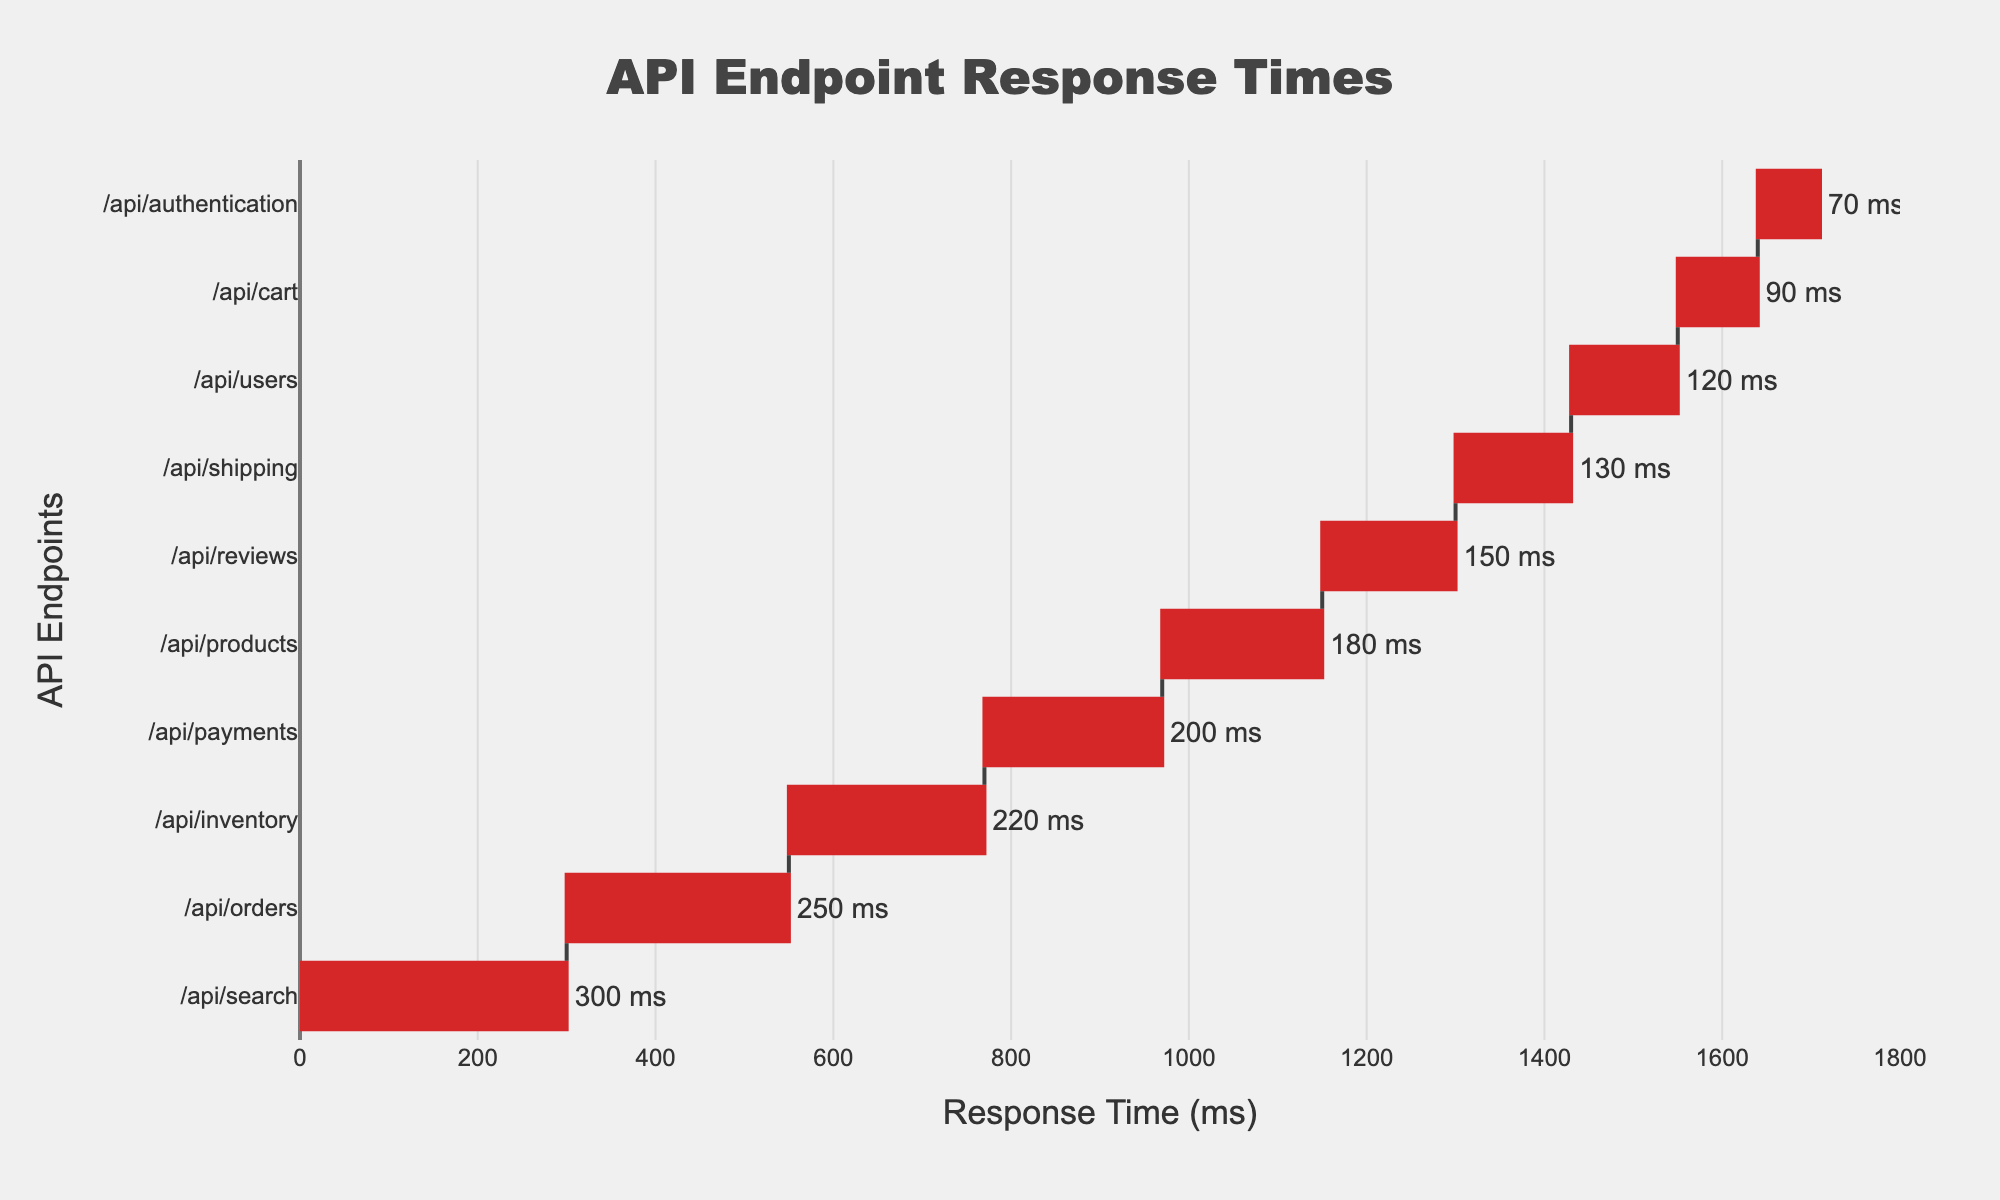What's the title of the chart? The title of the chart is prominently displayed at the top. It reads "API Endpoint Response Times."
Answer: API Endpoint Response Times How many API endpoints are displayed in the chart? To determine the number of API endpoints, count the total number of bars in the waterfall chart or refer to the number of y-axis labels.
Answer: 10 Which API endpoint has the highest response time? To find the API endpoint with the highest response time, look for the topmost bar since the data is sorted by response time in descending order.
Answer: /api/search What is the response time of the "/api/products" endpoint? Check the exact numeric value displayed at the end of the horizontal bar corresponding to the "/api/products" label. It shows "180 ms."
Answer: 180 ms Which endpoints have response times greater than 200 ms? Identify the endpoints with bars extending beyond the 200 ms mark on the x-axis or read the numeric values for each endpoint to see if they exceed 200 ms. These are "/api/search", "/api/orders", "/api/inventory", and "/api/payments."
Answer: /api/search, /api/orders, /api/inventory, /api/payments What is the difference in response time between "/api/cart" and "/api/shipping"? Find the response times for "/api/cart" and "/api/shipping" (90 ms and 130 ms, respectively). Subtract the smaller value (90 ms) from the larger value (130 ms).
Answer: 40 ms What's the average response time of the listed API endpoints? Sum all response times and divide by the number of endpoints. Total response time = 120 + 180 + 250 + 90 + 70 + 300 + 150 + 200 + 220 + 130 = 1710 ms. Number of endpoints = 10. Average response time = 1710 / 10 ms.
Answer: 171 ms How does the response time of "/api/users" compare to "/api/authentication"? Compare the numeric values of the response times for these endpoints. "/api/users" has 120 ms, and "/api/authentication" has 70 ms. "/api/users" has a higher response time.
Answer: /api/users is higher Which endpoint falls between "/api/reviews" and "/api/shipping" in terms of response time? Check the response times for "/api/reviews" (150 ms) and "/api/shipping" (130 ms). Identify the endpoint that has a response time falling between these two values.
Answer: /api/shipping 